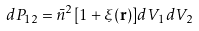Convert formula to latex. <formula><loc_0><loc_0><loc_500><loc_500>d P _ { 1 2 } = \bar { n } ^ { 2 } [ 1 + \xi ( { \mathbf r } ) ] d V _ { 1 } d V _ { 2 }</formula> 